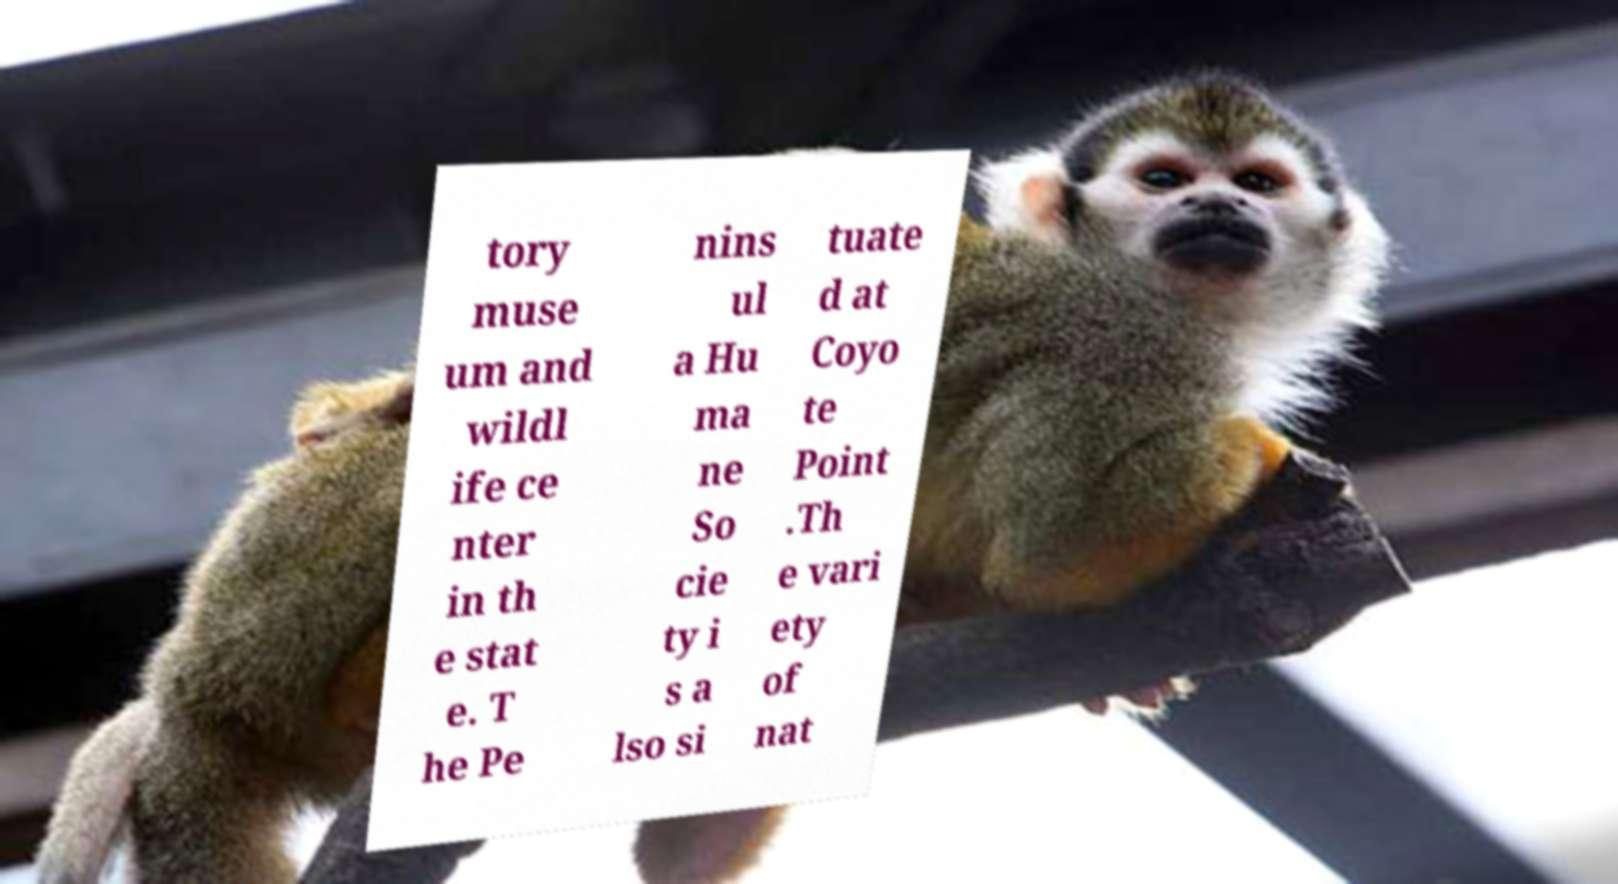Please read and relay the text visible in this image. What does it say? tory muse um and wildl ife ce nter in th e stat e. T he Pe nins ul a Hu ma ne So cie ty i s a lso si tuate d at Coyo te Point .Th e vari ety of nat 